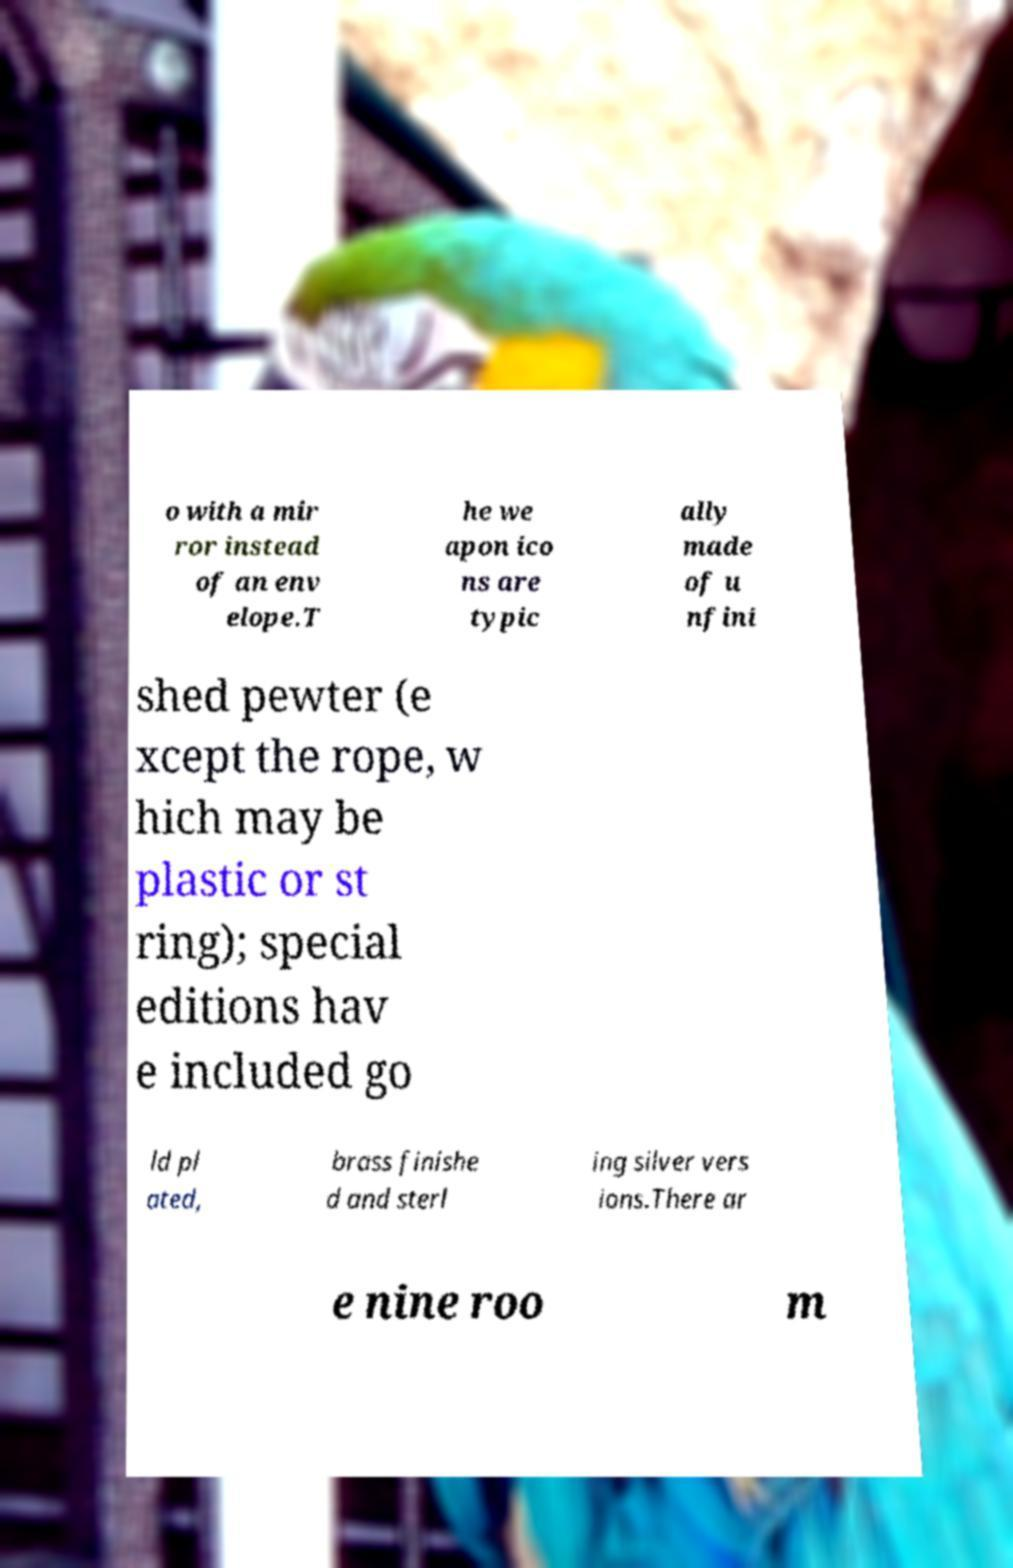There's text embedded in this image that I need extracted. Can you transcribe it verbatim? o with a mir ror instead of an env elope.T he we apon ico ns are typic ally made of u nfini shed pewter (e xcept the rope, w hich may be plastic or st ring); special editions hav e included go ld pl ated, brass finishe d and sterl ing silver vers ions.There ar e nine roo m 